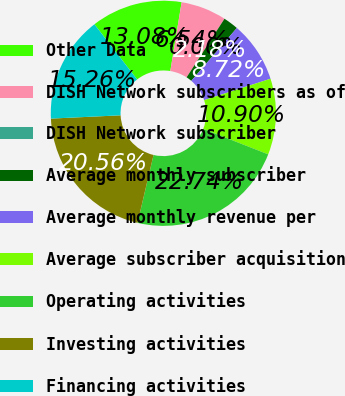Convert chart to OTSL. <chart><loc_0><loc_0><loc_500><loc_500><pie_chart><fcel>Other Data<fcel>DISH Network subscribers as of<fcel>DISH Network subscriber<fcel>Average monthly subscriber<fcel>Average monthly revenue per<fcel>Average subscriber acquisition<fcel>Operating activities<fcel>Investing activities<fcel>Financing activities<nl><fcel>13.08%<fcel>6.54%<fcel>0.0%<fcel>2.18%<fcel>8.72%<fcel>10.9%<fcel>22.74%<fcel>20.56%<fcel>15.26%<nl></chart> 